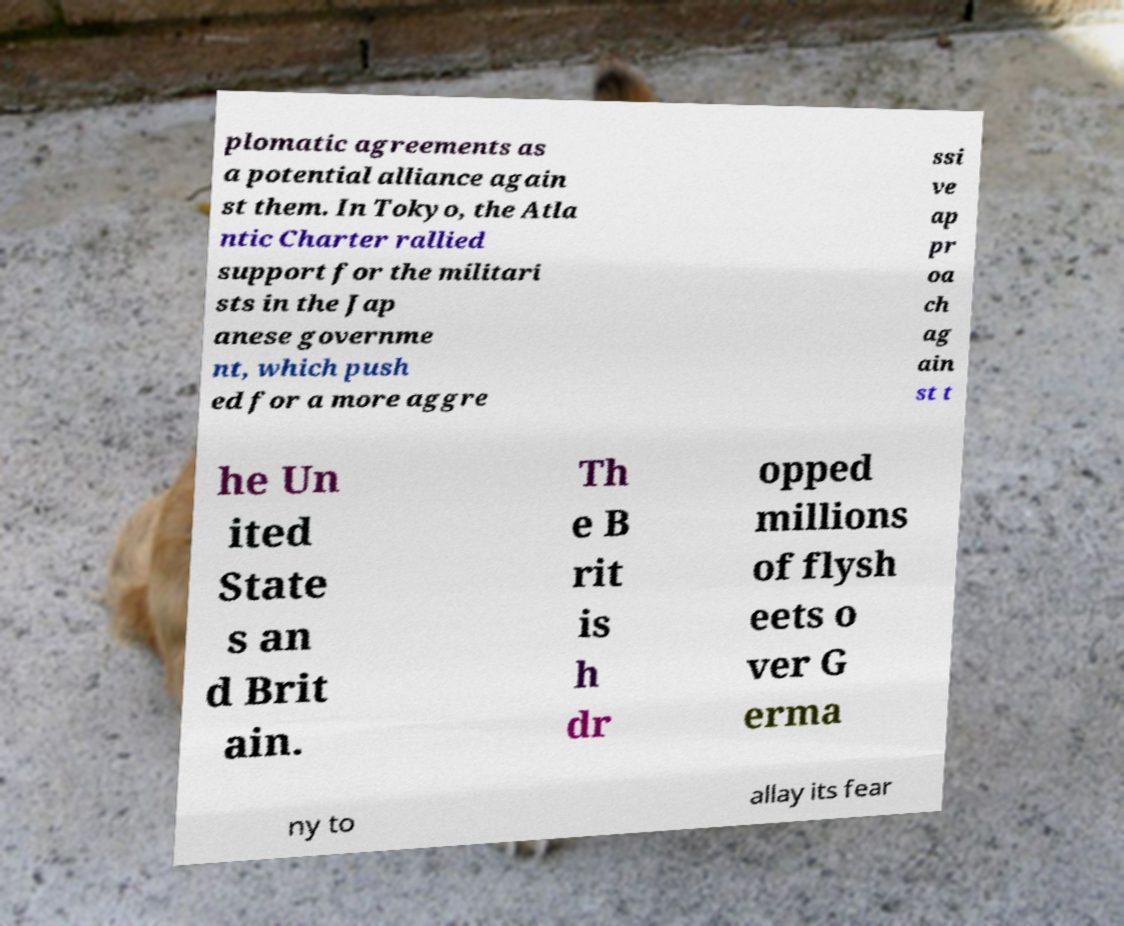Please read and relay the text visible in this image. What does it say? plomatic agreements as a potential alliance again st them. In Tokyo, the Atla ntic Charter rallied support for the militari sts in the Jap anese governme nt, which push ed for a more aggre ssi ve ap pr oa ch ag ain st t he Un ited State s an d Brit ain. Th e B rit is h dr opped millions of flysh eets o ver G erma ny to allay its fear 